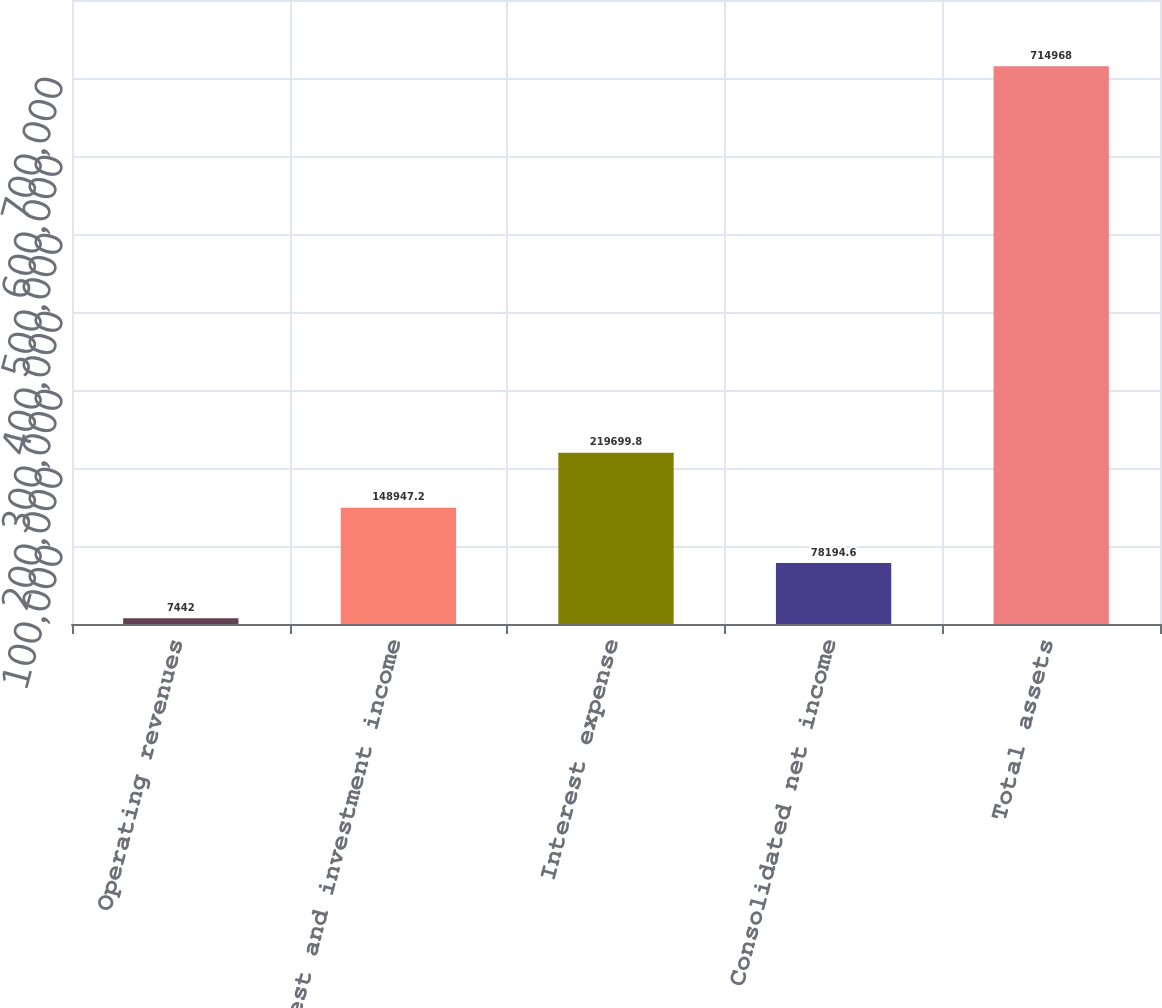<chart> <loc_0><loc_0><loc_500><loc_500><bar_chart><fcel>Operating revenues<fcel>Interest and investment income<fcel>Interest expense<fcel>Consolidated net income<fcel>Total assets<nl><fcel>7442<fcel>148947<fcel>219700<fcel>78194.6<fcel>714968<nl></chart> 